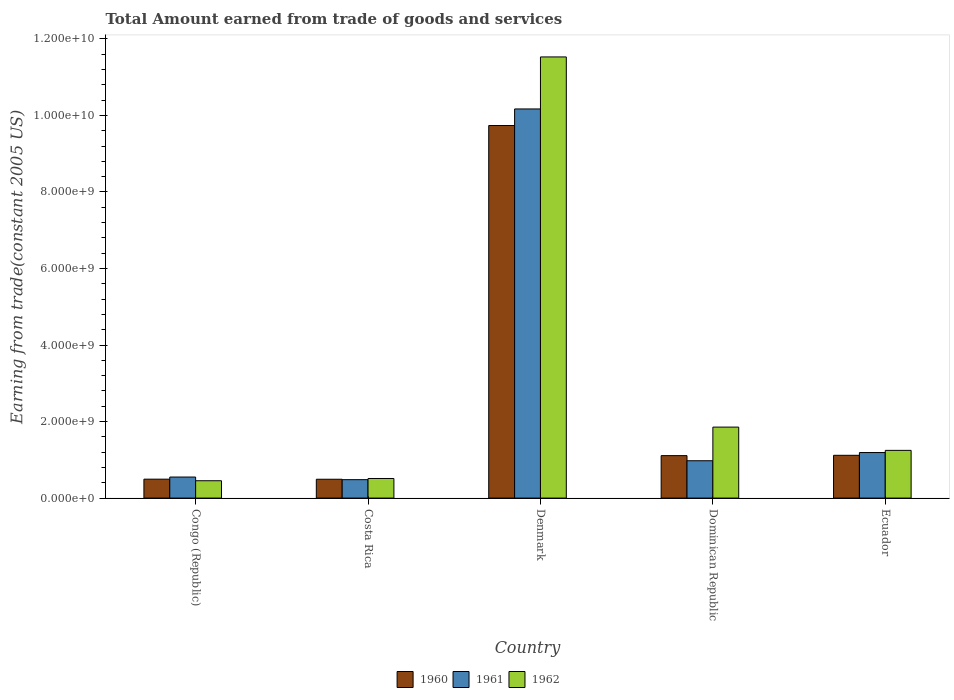What is the label of the 2nd group of bars from the left?
Offer a terse response. Costa Rica. What is the total amount earned by trading goods and services in 1960 in Congo (Republic)?
Keep it short and to the point. 4.95e+08. Across all countries, what is the maximum total amount earned by trading goods and services in 1962?
Ensure brevity in your answer.  1.15e+1. Across all countries, what is the minimum total amount earned by trading goods and services in 1961?
Offer a terse response. 4.81e+08. In which country was the total amount earned by trading goods and services in 1962 maximum?
Make the answer very short. Denmark. In which country was the total amount earned by trading goods and services in 1960 minimum?
Provide a short and direct response. Costa Rica. What is the total total amount earned by trading goods and services in 1960 in the graph?
Your answer should be compact. 1.30e+1. What is the difference between the total amount earned by trading goods and services in 1961 in Denmark and that in Ecuador?
Give a very brief answer. 8.98e+09. What is the difference between the total amount earned by trading goods and services in 1962 in Ecuador and the total amount earned by trading goods and services in 1961 in Costa Rica?
Keep it short and to the point. 7.66e+08. What is the average total amount earned by trading goods and services in 1962 per country?
Provide a succinct answer. 3.12e+09. What is the difference between the total amount earned by trading goods and services of/in 1961 and total amount earned by trading goods and services of/in 1960 in Denmark?
Make the answer very short. 4.33e+08. In how many countries, is the total amount earned by trading goods and services in 1962 greater than 6800000000 US$?
Provide a short and direct response. 1. What is the ratio of the total amount earned by trading goods and services in 1962 in Denmark to that in Ecuador?
Your answer should be very brief. 9.24. Is the total amount earned by trading goods and services in 1962 in Denmark less than that in Dominican Republic?
Make the answer very short. No. Is the difference between the total amount earned by trading goods and services in 1961 in Denmark and Dominican Republic greater than the difference between the total amount earned by trading goods and services in 1960 in Denmark and Dominican Republic?
Provide a short and direct response. Yes. What is the difference between the highest and the second highest total amount earned by trading goods and services in 1961?
Your answer should be very brief. -2.14e+08. What is the difference between the highest and the lowest total amount earned by trading goods and services in 1961?
Provide a short and direct response. 9.69e+09. What does the 2nd bar from the right in Costa Rica represents?
Keep it short and to the point. 1961. Is it the case that in every country, the sum of the total amount earned by trading goods and services in 1962 and total amount earned by trading goods and services in 1960 is greater than the total amount earned by trading goods and services in 1961?
Give a very brief answer. Yes. How many bars are there?
Ensure brevity in your answer.  15. What is the difference between two consecutive major ticks on the Y-axis?
Provide a short and direct response. 2.00e+09. Does the graph contain grids?
Provide a short and direct response. No. What is the title of the graph?
Your answer should be very brief. Total Amount earned from trade of goods and services. What is the label or title of the X-axis?
Give a very brief answer. Country. What is the label or title of the Y-axis?
Make the answer very short. Earning from trade(constant 2005 US). What is the Earning from trade(constant 2005 US) in 1960 in Congo (Republic)?
Offer a terse response. 4.95e+08. What is the Earning from trade(constant 2005 US) in 1961 in Congo (Republic)?
Provide a short and direct response. 5.50e+08. What is the Earning from trade(constant 2005 US) in 1962 in Congo (Republic)?
Offer a terse response. 4.53e+08. What is the Earning from trade(constant 2005 US) of 1960 in Costa Rica?
Give a very brief answer. 4.92e+08. What is the Earning from trade(constant 2005 US) in 1961 in Costa Rica?
Your response must be concise. 4.81e+08. What is the Earning from trade(constant 2005 US) in 1962 in Costa Rica?
Provide a short and direct response. 5.12e+08. What is the Earning from trade(constant 2005 US) of 1960 in Denmark?
Offer a terse response. 9.74e+09. What is the Earning from trade(constant 2005 US) in 1961 in Denmark?
Offer a terse response. 1.02e+1. What is the Earning from trade(constant 2005 US) in 1962 in Denmark?
Offer a terse response. 1.15e+1. What is the Earning from trade(constant 2005 US) in 1960 in Dominican Republic?
Ensure brevity in your answer.  1.11e+09. What is the Earning from trade(constant 2005 US) in 1961 in Dominican Republic?
Give a very brief answer. 9.76e+08. What is the Earning from trade(constant 2005 US) of 1962 in Dominican Republic?
Your response must be concise. 1.86e+09. What is the Earning from trade(constant 2005 US) of 1960 in Ecuador?
Your answer should be compact. 1.12e+09. What is the Earning from trade(constant 2005 US) in 1961 in Ecuador?
Provide a succinct answer. 1.19e+09. What is the Earning from trade(constant 2005 US) in 1962 in Ecuador?
Ensure brevity in your answer.  1.25e+09. Across all countries, what is the maximum Earning from trade(constant 2005 US) in 1960?
Give a very brief answer. 9.74e+09. Across all countries, what is the maximum Earning from trade(constant 2005 US) in 1961?
Provide a succinct answer. 1.02e+1. Across all countries, what is the maximum Earning from trade(constant 2005 US) in 1962?
Keep it short and to the point. 1.15e+1. Across all countries, what is the minimum Earning from trade(constant 2005 US) in 1960?
Provide a succinct answer. 4.92e+08. Across all countries, what is the minimum Earning from trade(constant 2005 US) in 1961?
Offer a very short reply. 4.81e+08. Across all countries, what is the minimum Earning from trade(constant 2005 US) in 1962?
Offer a terse response. 4.53e+08. What is the total Earning from trade(constant 2005 US) of 1960 in the graph?
Your answer should be compact. 1.30e+1. What is the total Earning from trade(constant 2005 US) of 1961 in the graph?
Provide a succinct answer. 1.34e+1. What is the total Earning from trade(constant 2005 US) in 1962 in the graph?
Provide a short and direct response. 1.56e+1. What is the difference between the Earning from trade(constant 2005 US) in 1960 in Congo (Republic) and that in Costa Rica?
Keep it short and to the point. 2.28e+06. What is the difference between the Earning from trade(constant 2005 US) in 1961 in Congo (Republic) and that in Costa Rica?
Ensure brevity in your answer.  6.87e+07. What is the difference between the Earning from trade(constant 2005 US) in 1962 in Congo (Republic) and that in Costa Rica?
Make the answer very short. -5.88e+07. What is the difference between the Earning from trade(constant 2005 US) in 1960 in Congo (Republic) and that in Denmark?
Offer a terse response. -9.24e+09. What is the difference between the Earning from trade(constant 2005 US) in 1961 in Congo (Republic) and that in Denmark?
Ensure brevity in your answer.  -9.62e+09. What is the difference between the Earning from trade(constant 2005 US) in 1962 in Congo (Republic) and that in Denmark?
Make the answer very short. -1.11e+1. What is the difference between the Earning from trade(constant 2005 US) of 1960 in Congo (Republic) and that in Dominican Republic?
Your response must be concise. -6.15e+08. What is the difference between the Earning from trade(constant 2005 US) in 1961 in Congo (Republic) and that in Dominican Republic?
Keep it short and to the point. -4.26e+08. What is the difference between the Earning from trade(constant 2005 US) in 1962 in Congo (Republic) and that in Dominican Republic?
Provide a short and direct response. -1.40e+09. What is the difference between the Earning from trade(constant 2005 US) in 1960 in Congo (Republic) and that in Ecuador?
Ensure brevity in your answer.  -6.23e+08. What is the difference between the Earning from trade(constant 2005 US) in 1961 in Congo (Republic) and that in Ecuador?
Keep it short and to the point. -6.40e+08. What is the difference between the Earning from trade(constant 2005 US) in 1962 in Congo (Republic) and that in Ecuador?
Ensure brevity in your answer.  -7.94e+08. What is the difference between the Earning from trade(constant 2005 US) in 1960 in Costa Rica and that in Denmark?
Keep it short and to the point. -9.24e+09. What is the difference between the Earning from trade(constant 2005 US) in 1961 in Costa Rica and that in Denmark?
Your answer should be compact. -9.69e+09. What is the difference between the Earning from trade(constant 2005 US) of 1962 in Costa Rica and that in Denmark?
Your answer should be compact. -1.10e+1. What is the difference between the Earning from trade(constant 2005 US) in 1960 in Costa Rica and that in Dominican Republic?
Make the answer very short. -6.17e+08. What is the difference between the Earning from trade(constant 2005 US) in 1961 in Costa Rica and that in Dominican Republic?
Your response must be concise. -4.95e+08. What is the difference between the Earning from trade(constant 2005 US) of 1962 in Costa Rica and that in Dominican Republic?
Offer a very short reply. -1.34e+09. What is the difference between the Earning from trade(constant 2005 US) of 1960 in Costa Rica and that in Ecuador?
Your answer should be very brief. -6.26e+08. What is the difference between the Earning from trade(constant 2005 US) in 1961 in Costa Rica and that in Ecuador?
Give a very brief answer. -7.09e+08. What is the difference between the Earning from trade(constant 2005 US) of 1962 in Costa Rica and that in Ecuador?
Your answer should be compact. -7.35e+08. What is the difference between the Earning from trade(constant 2005 US) in 1960 in Denmark and that in Dominican Republic?
Ensure brevity in your answer.  8.63e+09. What is the difference between the Earning from trade(constant 2005 US) of 1961 in Denmark and that in Dominican Republic?
Your answer should be very brief. 9.19e+09. What is the difference between the Earning from trade(constant 2005 US) in 1962 in Denmark and that in Dominican Republic?
Your response must be concise. 9.67e+09. What is the difference between the Earning from trade(constant 2005 US) in 1960 in Denmark and that in Ecuador?
Keep it short and to the point. 8.62e+09. What is the difference between the Earning from trade(constant 2005 US) in 1961 in Denmark and that in Ecuador?
Your answer should be very brief. 8.98e+09. What is the difference between the Earning from trade(constant 2005 US) of 1962 in Denmark and that in Ecuador?
Your answer should be compact. 1.03e+1. What is the difference between the Earning from trade(constant 2005 US) of 1960 in Dominican Republic and that in Ecuador?
Make the answer very short. -8.29e+06. What is the difference between the Earning from trade(constant 2005 US) of 1961 in Dominican Republic and that in Ecuador?
Your response must be concise. -2.14e+08. What is the difference between the Earning from trade(constant 2005 US) of 1962 in Dominican Republic and that in Ecuador?
Offer a very short reply. 6.08e+08. What is the difference between the Earning from trade(constant 2005 US) in 1960 in Congo (Republic) and the Earning from trade(constant 2005 US) in 1961 in Costa Rica?
Offer a very short reply. 1.32e+07. What is the difference between the Earning from trade(constant 2005 US) in 1960 in Congo (Republic) and the Earning from trade(constant 2005 US) in 1962 in Costa Rica?
Your response must be concise. -1.76e+07. What is the difference between the Earning from trade(constant 2005 US) of 1961 in Congo (Republic) and the Earning from trade(constant 2005 US) of 1962 in Costa Rica?
Make the answer very short. 3.80e+07. What is the difference between the Earning from trade(constant 2005 US) of 1960 in Congo (Republic) and the Earning from trade(constant 2005 US) of 1961 in Denmark?
Make the answer very short. -9.67e+09. What is the difference between the Earning from trade(constant 2005 US) in 1960 in Congo (Republic) and the Earning from trade(constant 2005 US) in 1962 in Denmark?
Your answer should be compact. -1.10e+1. What is the difference between the Earning from trade(constant 2005 US) of 1961 in Congo (Republic) and the Earning from trade(constant 2005 US) of 1962 in Denmark?
Offer a very short reply. -1.10e+1. What is the difference between the Earning from trade(constant 2005 US) in 1960 in Congo (Republic) and the Earning from trade(constant 2005 US) in 1961 in Dominican Republic?
Offer a terse response. -4.81e+08. What is the difference between the Earning from trade(constant 2005 US) in 1960 in Congo (Republic) and the Earning from trade(constant 2005 US) in 1962 in Dominican Republic?
Offer a very short reply. -1.36e+09. What is the difference between the Earning from trade(constant 2005 US) in 1961 in Congo (Republic) and the Earning from trade(constant 2005 US) in 1962 in Dominican Republic?
Provide a succinct answer. -1.30e+09. What is the difference between the Earning from trade(constant 2005 US) in 1960 in Congo (Republic) and the Earning from trade(constant 2005 US) in 1961 in Ecuador?
Your answer should be compact. -6.96e+08. What is the difference between the Earning from trade(constant 2005 US) in 1960 in Congo (Republic) and the Earning from trade(constant 2005 US) in 1962 in Ecuador?
Offer a very short reply. -7.52e+08. What is the difference between the Earning from trade(constant 2005 US) in 1961 in Congo (Republic) and the Earning from trade(constant 2005 US) in 1962 in Ecuador?
Keep it short and to the point. -6.97e+08. What is the difference between the Earning from trade(constant 2005 US) in 1960 in Costa Rica and the Earning from trade(constant 2005 US) in 1961 in Denmark?
Offer a terse response. -9.68e+09. What is the difference between the Earning from trade(constant 2005 US) of 1960 in Costa Rica and the Earning from trade(constant 2005 US) of 1962 in Denmark?
Offer a very short reply. -1.10e+1. What is the difference between the Earning from trade(constant 2005 US) of 1961 in Costa Rica and the Earning from trade(constant 2005 US) of 1962 in Denmark?
Provide a short and direct response. -1.10e+1. What is the difference between the Earning from trade(constant 2005 US) in 1960 in Costa Rica and the Earning from trade(constant 2005 US) in 1961 in Dominican Republic?
Your answer should be compact. -4.84e+08. What is the difference between the Earning from trade(constant 2005 US) of 1960 in Costa Rica and the Earning from trade(constant 2005 US) of 1962 in Dominican Republic?
Offer a terse response. -1.36e+09. What is the difference between the Earning from trade(constant 2005 US) of 1961 in Costa Rica and the Earning from trade(constant 2005 US) of 1962 in Dominican Republic?
Ensure brevity in your answer.  -1.37e+09. What is the difference between the Earning from trade(constant 2005 US) in 1960 in Costa Rica and the Earning from trade(constant 2005 US) in 1961 in Ecuador?
Give a very brief answer. -6.98e+08. What is the difference between the Earning from trade(constant 2005 US) in 1960 in Costa Rica and the Earning from trade(constant 2005 US) in 1962 in Ecuador?
Your response must be concise. -7.55e+08. What is the difference between the Earning from trade(constant 2005 US) of 1961 in Costa Rica and the Earning from trade(constant 2005 US) of 1962 in Ecuador?
Your answer should be compact. -7.66e+08. What is the difference between the Earning from trade(constant 2005 US) of 1960 in Denmark and the Earning from trade(constant 2005 US) of 1961 in Dominican Republic?
Offer a terse response. 8.76e+09. What is the difference between the Earning from trade(constant 2005 US) of 1960 in Denmark and the Earning from trade(constant 2005 US) of 1962 in Dominican Republic?
Your answer should be compact. 7.88e+09. What is the difference between the Earning from trade(constant 2005 US) of 1961 in Denmark and the Earning from trade(constant 2005 US) of 1962 in Dominican Republic?
Your answer should be very brief. 8.31e+09. What is the difference between the Earning from trade(constant 2005 US) of 1960 in Denmark and the Earning from trade(constant 2005 US) of 1961 in Ecuador?
Ensure brevity in your answer.  8.55e+09. What is the difference between the Earning from trade(constant 2005 US) of 1960 in Denmark and the Earning from trade(constant 2005 US) of 1962 in Ecuador?
Provide a succinct answer. 8.49e+09. What is the difference between the Earning from trade(constant 2005 US) of 1961 in Denmark and the Earning from trade(constant 2005 US) of 1962 in Ecuador?
Keep it short and to the point. 8.92e+09. What is the difference between the Earning from trade(constant 2005 US) in 1960 in Dominican Republic and the Earning from trade(constant 2005 US) in 1961 in Ecuador?
Keep it short and to the point. -8.07e+07. What is the difference between the Earning from trade(constant 2005 US) of 1960 in Dominican Republic and the Earning from trade(constant 2005 US) of 1962 in Ecuador?
Offer a terse response. -1.37e+08. What is the difference between the Earning from trade(constant 2005 US) in 1961 in Dominican Republic and the Earning from trade(constant 2005 US) in 1962 in Ecuador?
Offer a very short reply. -2.71e+08. What is the average Earning from trade(constant 2005 US) of 1960 per country?
Provide a succinct answer. 2.59e+09. What is the average Earning from trade(constant 2005 US) in 1961 per country?
Ensure brevity in your answer.  2.67e+09. What is the average Earning from trade(constant 2005 US) of 1962 per country?
Keep it short and to the point. 3.12e+09. What is the difference between the Earning from trade(constant 2005 US) in 1960 and Earning from trade(constant 2005 US) in 1961 in Congo (Republic)?
Offer a terse response. -5.56e+07. What is the difference between the Earning from trade(constant 2005 US) in 1960 and Earning from trade(constant 2005 US) in 1962 in Congo (Republic)?
Give a very brief answer. 4.12e+07. What is the difference between the Earning from trade(constant 2005 US) in 1961 and Earning from trade(constant 2005 US) in 1962 in Congo (Republic)?
Your response must be concise. 9.68e+07. What is the difference between the Earning from trade(constant 2005 US) in 1960 and Earning from trade(constant 2005 US) in 1961 in Costa Rica?
Ensure brevity in your answer.  1.09e+07. What is the difference between the Earning from trade(constant 2005 US) in 1960 and Earning from trade(constant 2005 US) in 1962 in Costa Rica?
Your answer should be very brief. -1.99e+07. What is the difference between the Earning from trade(constant 2005 US) in 1961 and Earning from trade(constant 2005 US) in 1962 in Costa Rica?
Your answer should be compact. -3.08e+07. What is the difference between the Earning from trade(constant 2005 US) in 1960 and Earning from trade(constant 2005 US) in 1961 in Denmark?
Ensure brevity in your answer.  -4.33e+08. What is the difference between the Earning from trade(constant 2005 US) in 1960 and Earning from trade(constant 2005 US) in 1962 in Denmark?
Keep it short and to the point. -1.79e+09. What is the difference between the Earning from trade(constant 2005 US) in 1961 and Earning from trade(constant 2005 US) in 1962 in Denmark?
Provide a succinct answer. -1.36e+09. What is the difference between the Earning from trade(constant 2005 US) in 1960 and Earning from trade(constant 2005 US) in 1961 in Dominican Republic?
Make the answer very short. 1.34e+08. What is the difference between the Earning from trade(constant 2005 US) in 1960 and Earning from trade(constant 2005 US) in 1962 in Dominican Republic?
Keep it short and to the point. -7.45e+08. What is the difference between the Earning from trade(constant 2005 US) of 1961 and Earning from trade(constant 2005 US) of 1962 in Dominican Republic?
Make the answer very short. -8.79e+08. What is the difference between the Earning from trade(constant 2005 US) of 1960 and Earning from trade(constant 2005 US) of 1961 in Ecuador?
Provide a succinct answer. -7.24e+07. What is the difference between the Earning from trade(constant 2005 US) of 1960 and Earning from trade(constant 2005 US) of 1962 in Ecuador?
Provide a short and direct response. -1.29e+08. What is the difference between the Earning from trade(constant 2005 US) in 1961 and Earning from trade(constant 2005 US) in 1962 in Ecuador?
Provide a succinct answer. -5.67e+07. What is the ratio of the Earning from trade(constant 2005 US) of 1961 in Congo (Republic) to that in Costa Rica?
Your answer should be compact. 1.14. What is the ratio of the Earning from trade(constant 2005 US) of 1962 in Congo (Republic) to that in Costa Rica?
Ensure brevity in your answer.  0.89. What is the ratio of the Earning from trade(constant 2005 US) in 1960 in Congo (Republic) to that in Denmark?
Offer a terse response. 0.05. What is the ratio of the Earning from trade(constant 2005 US) in 1961 in Congo (Republic) to that in Denmark?
Keep it short and to the point. 0.05. What is the ratio of the Earning from trade(constant 2005 US) of 1962 in Congo (Republic) to that in Denmark?
Make the answer very short. 0.04. What is the ratio of the Earning from trade(constant 2005 US) of 1960 in Congo (Republic) to that in Dominican Republic?
Provide a succinct answer. 0.45. What is the ratio of the Earning from trade(constant 2005 US) of 1961 in Congo (Republic) to that in Dominican Republic?
Offer a very short reply. 0.56. What is the ratio of the Earning from trade(constant 2005 US) of 1962 in Congo (Republic) to that in Dominican Republic?
Make the answer very short. 0.24. What is the ratio of the Earning from trade(constant 2005 US) in 1960 in Congo (Republic) to that in Ecuador?
Give a very brief answer. 0.44. What is the ratio of the Earning from trade(constant 2005 US) of 1961 in Congo (Republic) to that in Ecuador?
Your response must be concise. 0.46. What is the ratio of the Earning from trade(constant 2005 US) in 1962 in Congo (Republic) to that in Ecuador?
Your answer should be very brief. 0.36. What is the ratio of the Earning from trade(constant 2005 US) of 1960 in Costa Rica to that in Denmark?
Provide a short and direct response. 0.05. What is the ratio of the Earning from trade(constant 2005 US) in 1961 in Costa Rica to that in Denmark?
Your answer should be compact. 0.05. What is the ratio of the Earning from trade(constant 2005 US) of 1962 in Costa Rica to that in Denmark?
Ensure brevity in your answer.  0.04. What is the ratio of the Earning from trade(constant 2005 US) in 1960 in Costa Rica to that in Dominican Republic?
Give a very brief answer. 0.44. What is the ratio of the Earning from trade(constant 2005 US) of 1961 in Costa Rica to that in Dominican Republic?
Ensure brevity in your answer.  0.49. What is the ratio of the Earning from trade(constant 2005 US) in 1962 in Costa Rica to that in Dominican Republic?
Make the answer very short. 0.28. What is the ratio of the Earning from trade(constant 2005 US) in 1960 in Costa Rica to that in Ecuador?
Offer a terse response. 0.44. What is the ratio of the Earning from trade(constant 2005 US) of 1961 in Costa Rica to that in Ecuador?
Your response must be concise. 0.4. What is the ratio of the Earning from trade(constant 2005 US) in 1962 in Costa Rica to that in Ecuador?
Provide a short and direct response. 0.41. What is the ratio of the Earning from trade(constant 2005 US) in 1960 in Denmark to that in Dominican Republic?
Your answer should be very brief. 8.77. What is the ratio of the Earning from trade(constant 2005 US) of 1961 in Denmark to that in Dominican Republic?
Offer a very short reply. 10.42. What is the ratio of the Earning from trade(constant 2005 US) of 1962 in Denmark to that in Dominican Republic?
Give a very brief answer. 6.21. What is the ratio of the Earning from trade(constant 2005 US) in 1960 in Denmark to that in Ecuador?
Keep it short and to the point. 8.71. What is the ratio of the Earning from trade(constant 2005 US) in 1961 in Denmark to that in Ecuador?
Give a very brief answer. 8.54. What is the ratio of the Earning from trade(constant 2005 US) in 1962 in Denmark to that in Ecuador?
Provide a succinct answer. 9.24. What is the ratio of the Earning from trade(constant 2005 US) in 1961 in Dominican Republic to that in Ecuador?
Offer a terse response. 0.82. What is the ratio of the Earning from trade(constant 2005 US) in 1962 in Dominican Republic to that in Ecuador?
Give a very brief answer. 1.49. What is the difference between the highest and the second highest Earning from trade(constant 2005 US) in 1960?
Your response must be concise. 8.62e+09. What is the difference between the highest and the second highest Earning from trade(constant 2005 US) of 1961?
Give a very brief answer. 8.98e+09. What is the difference between the highest and the second highest Earning from trade(constant 2005 US) in 1962?
Provide a succinct answer. 9.67e+09. What is the difference between the highest and the lowest Earning from trade(constant 2005 US) in 1960?
Offer a very short reply. 9.24e+09. What is the difference between the highest and the lowest Earning from trade(constant 2005 US) in 1961?
Keep it short and to the point. 9.69e+09. What is the difference between the highest and the lowest Earning from trade(constant 2005 US) in 1962?
Your response must be concise. 1.11e+1. 